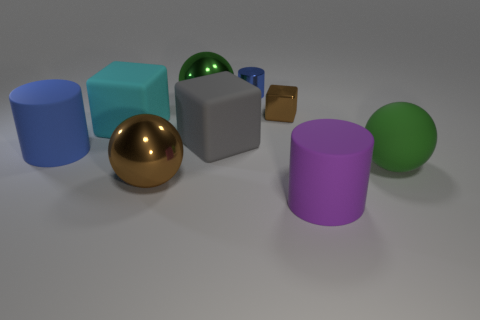Subtract all metallic balls. How many balls are left? 1 Subtract all red cylinders. How many green spheres are left? 2 Subtract all green balls. How many balls are left? 1 Subtract 0 cyan cylinders. How many objects are left? 9 Subtract all balls. How many objects are left? 6 Subtract 2 blocks. How many blocks are left? 1 Subtract all cyan spheres. Subtract all purple cubes. How many spheres are left? 3 Subtract all big blocks. Subtract all tiny yellow shiny blocks. How many objects are left? 7 Add 2 big blue cylinders. How many big blue cylinders are left? 3 Add 4 purple objects. How many purple objects exist? 5 